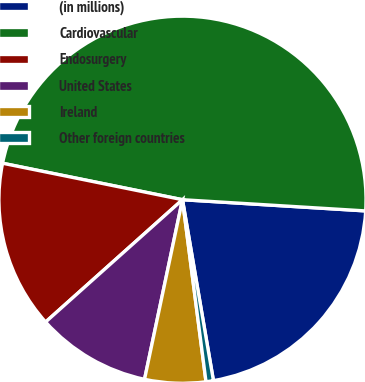Convert chart to OTSL. <chart><loc_0><loc_0><loc_500><loc_500><pie_chart><fcel>(in millions)<fcel>Cardiovascular<fcel>Endosurgery<fcel>United States<fcel>Ireland<fcel>Other foreign countries<nl><fcel>21.33%<fcel>47.79%<fcel>14.79%<fcel>10.08%<fcel>5.36%<fcel>0.65%<nl></chart> 